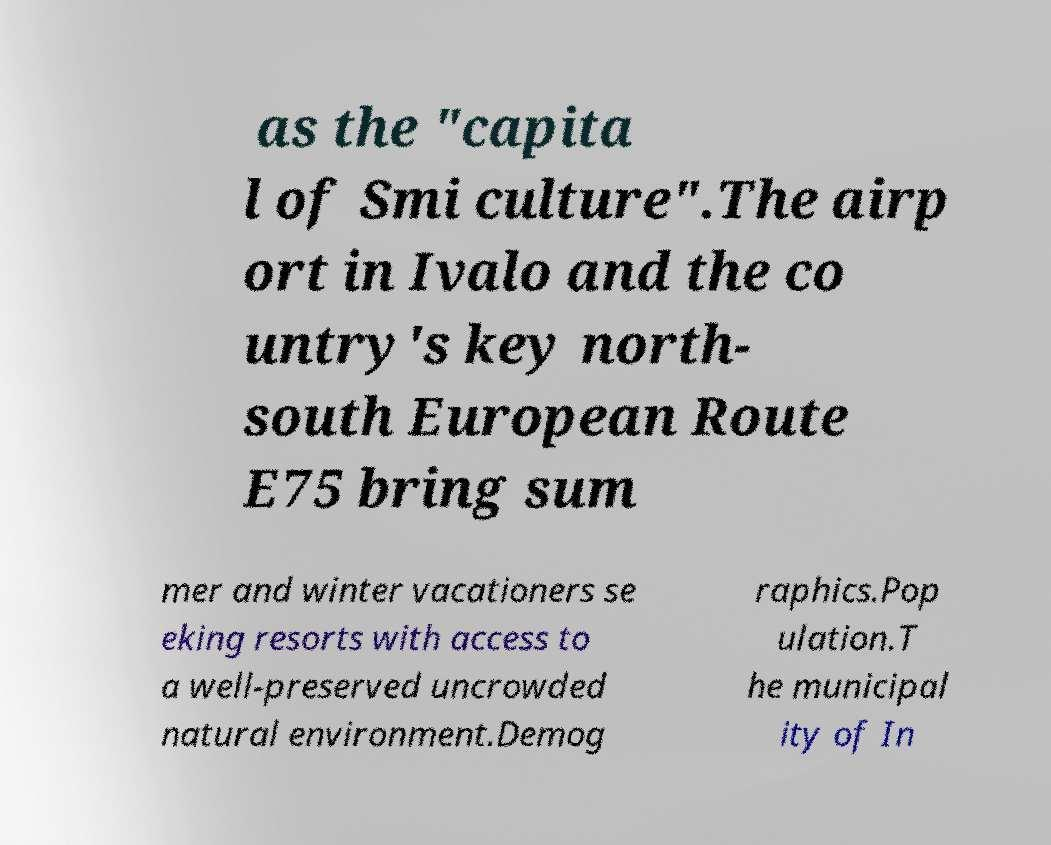Please read and relay the text visible in this image. What does it say? as the "capita l of Smi culture".The airp ort in Ivalo and the co untry's key north- south European Route E75 bring sum mer and winter vacationers se eking resorts with access to a well-preserved uncrowded natural environment.Demog raphics.Pop ulation.T he municipal ity of In 